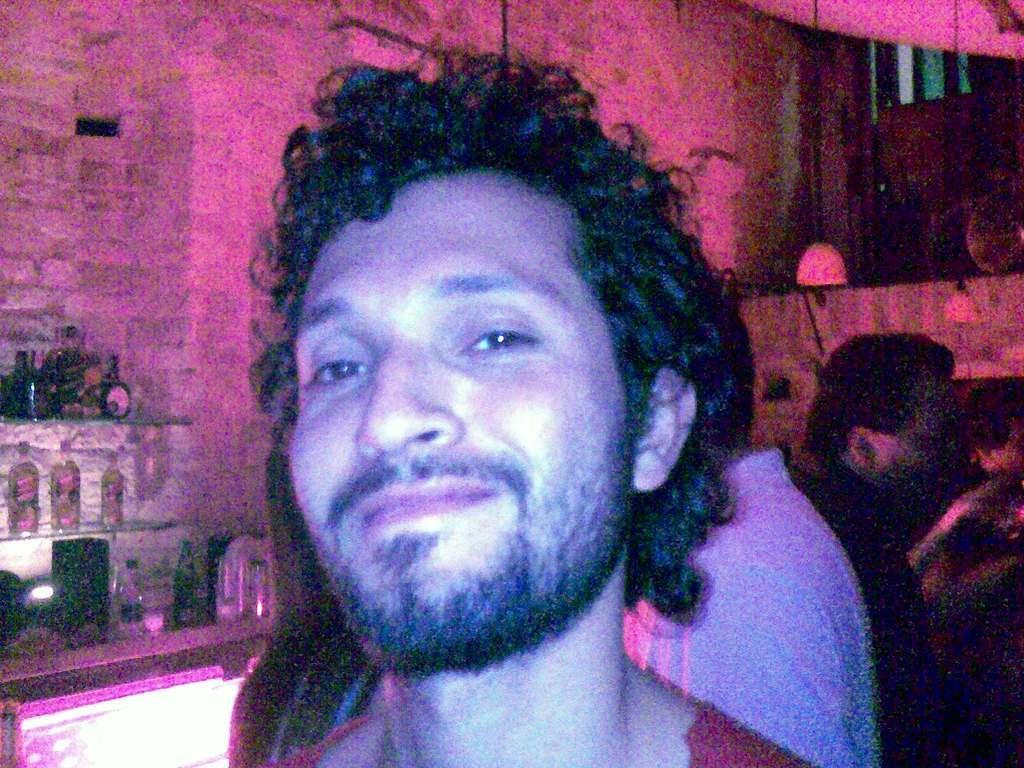Please provide a concise description of this image. This picture describes about group of people, on the left side of the image we can see few bottles in the racks. 